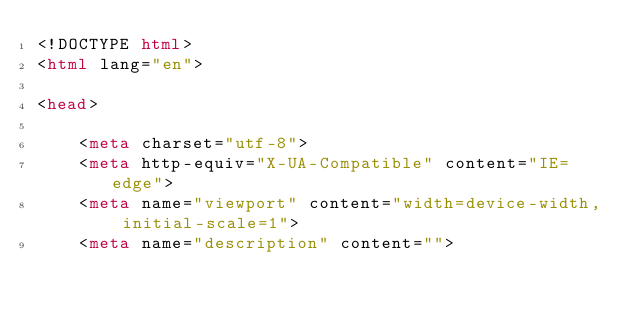Convert code to text. <code><loc_0><loc_0><loc_500><loc_500><_HTML_><!DOCTYPE html>
<html lang="en">

<head>

    <meta charset="utf-8">
    <meta http-equiv="X-UA-Compatible" content="IE=edge">
    <meta name="viewport" content="width=device-width, initial-scale=1">
    <meta name="description" content=""></code> 